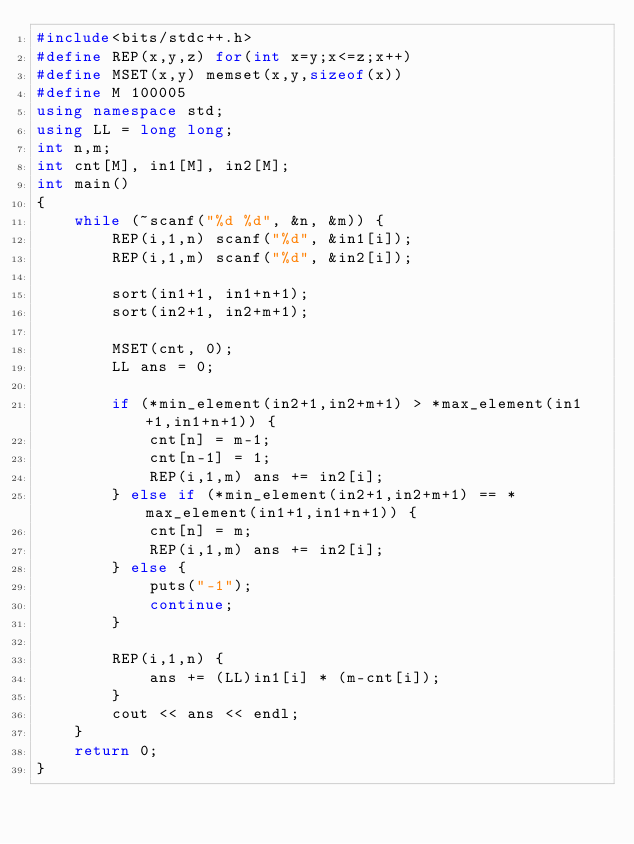<code> <loc_0><loc_0><loc_500><loc_500><_C++_>#include<bits/stdc++.h>
#define REP(x,y,z) for(int x=y;x<=z;x++)
#define MSET(x,y) memset(x,y,sizeof(x))
#define M 100005
using namespace std;
using LL = long long;
int n,m;
int cnt[M], in1[M], in2[M];
int main()
{
    while (~scanf("%d %d", &n, &m)) {
        REP(i,1,n) scanf("%d", &in1[i]);
        REP(i,1,m) scanf("%d", &in2[i]);

        sort(in1+1, in1+n+1);
        sort(in2+1, in2+m+1);

        MSET(cnt, 0);
        LL ans = 0;

        if (*min_element(in2+1,in2+m+1) > *max_element(in1+1,in1+n+1)) {
            cnt[n] = m-1;
            cnt[n-1] = 1;
            REP(i,1,m) ans += in2[i];
        } else if (*min_element(in2+1,in2+m+1) == *max_element(in1+1,in1+n+1)) {
            cnt[n] = m;
            REP(i,1,m) ans += in2[i];
        } else {
            puts("-1");
            continue;
        }

        REP(i,1,n) {
            ans += (LL)in1[i] * (m-cnt[i]);
        }
        cout << ans << endl;
    }
    return 0;
}

</code> 